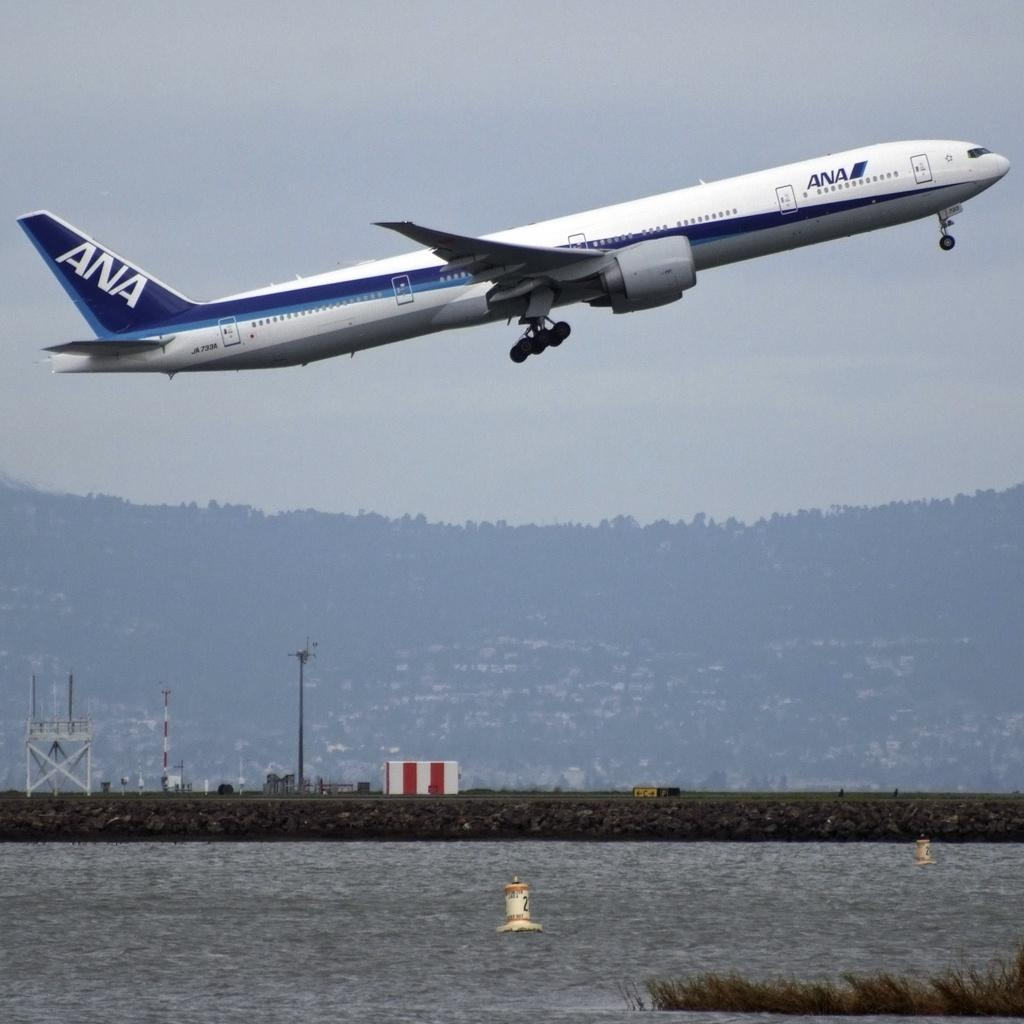Provide a one-sentence caption for the provided image. a plane with ANA on the side of it. 